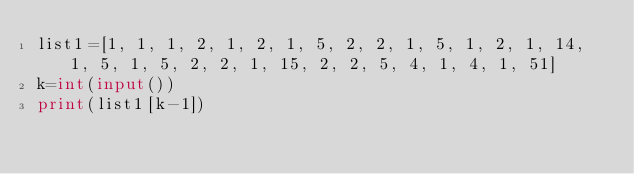<code> <loc_0><loc_0><loc_500><loc_500><_Python_>list1=[1, 1, 1, 2, 1, 2, 1, 5, 2, 2, 1, 5, 1, 2, 1, 14, 1, 5, 1, 5, 2, 2, 1, 15, 2, 2, 5, 4, 1, 4, 1, 51]
k=int(input())
print(list1[k-1])</code> 